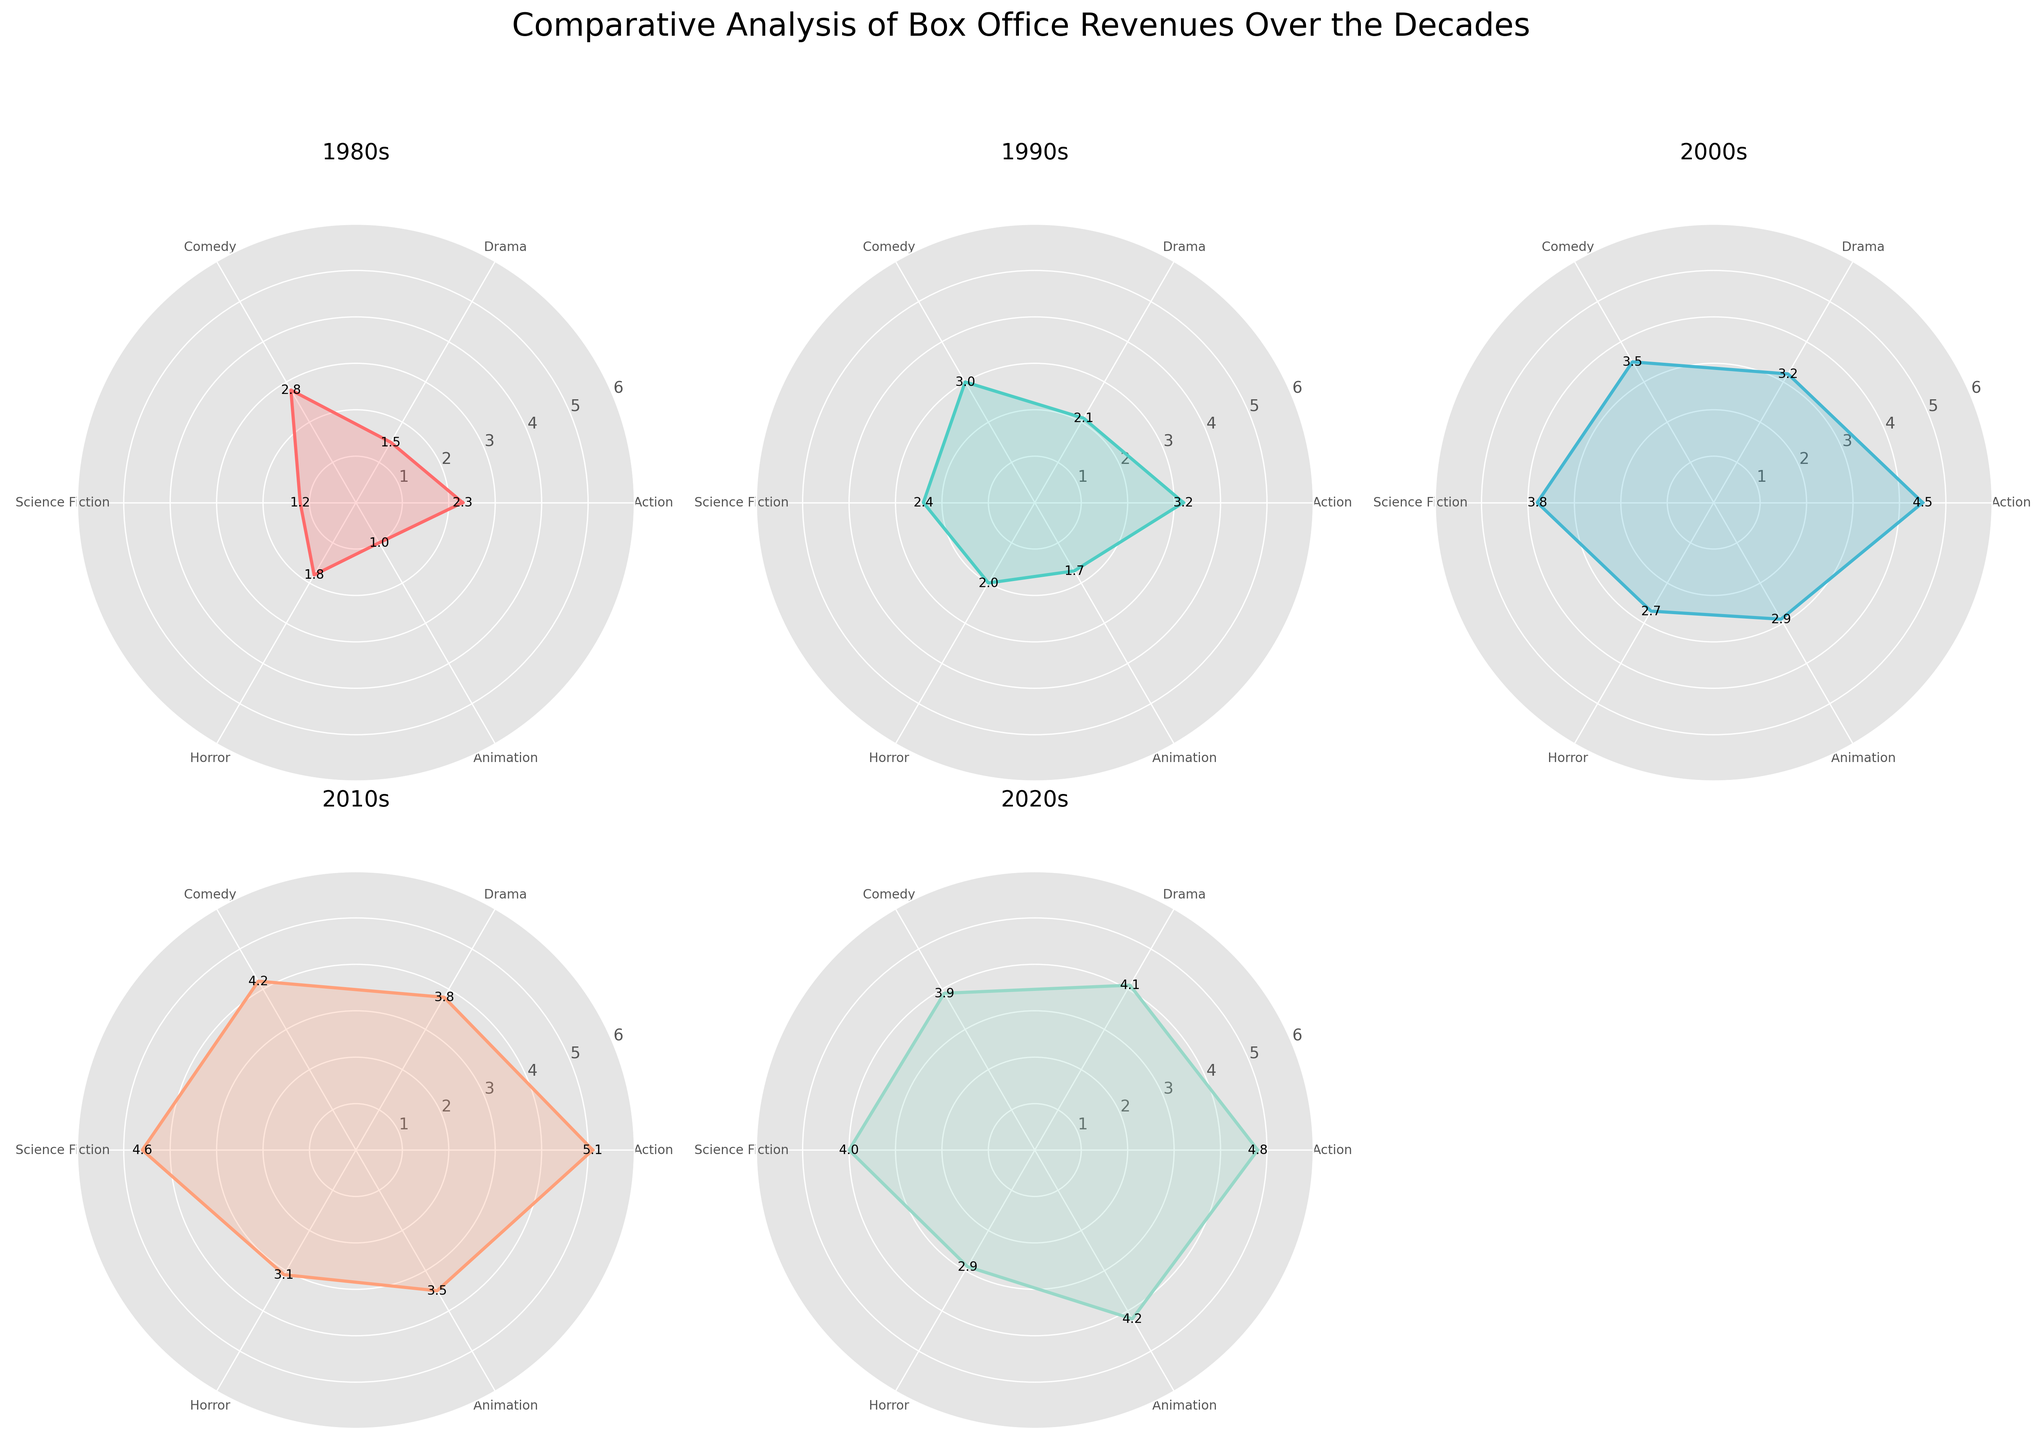What is the color used for the 1980s subplot? The subplot for each decade is assigned a unique color. In this case, the 1980s subplot uses the first color from the custom color palette, which is a shade of red.
Answer: Red Which decade has the highest value for Science Fiction? To determine which decade has the highest value for Science Fiction, we look at each subplot and find the point corresponding to Science Fiction. The values are: 1980s (1.2), 1990s (2.4), 2000s (3.8), 2010s (4.6), 2020s (4.0). Thus, 2010s have the highest value.
Answer: 2010s What is the average value for Action films across all decades? Add the values for Action films from each decade and divide by the number of decades. (2.3 + 3.2 + 4.5 + 5.1 + 4.8) / 5 = 19.9 / 5 = 3.98
Answer: 3.98 During which decade was the revenue for Horror films the lowest? Look at the value for Horror films in each subplot. The values are: 1980s (1.8), 1990s (2.0), 2000s (2.7), 2010s (3.1), 2020s (2.9). Thus, the lowest revenue for Horror films was in the 1980s.
Answer: 1980s Compare the box office revenue for Animation in the 2000s vs. the 2020s. Which decade had higher revenue and by how much? Compare the values for Animation: 2000s (2.9) and 2020s (4.2). The difference is 4.2 - 2.9 = 1.3, indicating that the 2020s had higher revenue by 1.3 units.
Answer: 2020s by 1.3 How many different genres are displayed in each radar chart? Each radar chart displays the same genres, which can be counted as Action, Drama, Comedy, Science Fiction, Horror, and Animation, totaling 6 genres.
Answer: 6 What is the title of the figure? The title of the figure is written at the top and states, "Comparative Analysis of Box Office Revenues Over the Decades".
Answer: Comparative Analysis of Box Office Revenues Over the Decades Which genre saw the most consistent increase in revenue from the 1980s to the 2020s? To find which genre saw the most consistent increase, we look for a genre whose values rise steadily over the decades without any drops. Action shows consistent growth: 1980s (2.3), 1990s (3.2), 2000s (4.5), 2010s (5.1), 2020s (4.8).
Answer: Action 